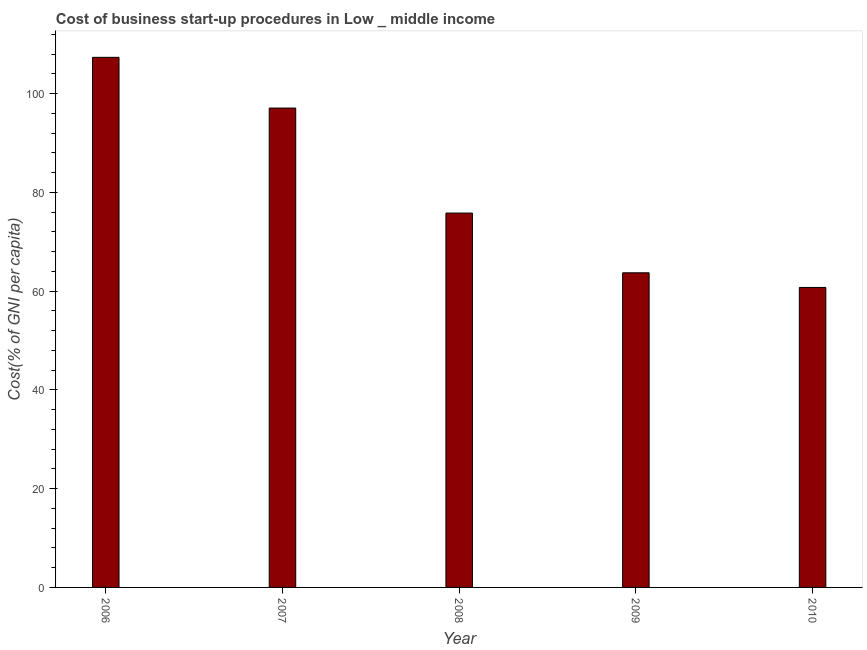Does the graph contain any zero values?
Your answer should be compact. No. What is the title of the graph?
Make the answer very short. Cost of business start-up procedures in Low _ middle income. What is the label or title of the Y-axis?
Provide a succinct answer. Cost(% of GNI per capita). What is the cost of business startup procedures in 2009?
Your answer should be very brief. 63.72. Across all years, what is the maximum cost of business startup procedures?
Provide a succinct answer. 107.35. Across all years, what is the minimum cost of business startup procedures?
Provide a succinct answer. 60.75. In which year was the cost of business startup procedures maximum?
Give a very brief answer. 2006. In which year was the cost of business startup procedures minimum?
Ensure brevity in your answer.  2010. What is the sum of the cost of business startup procedures?
Make the answer very short. 404.7. What is the difference between the cost of business startup procedures in 2007 and 2008?
Your answer should be compact. 21.27. What is the average cost of business startup procedures per year?
Ensure brevity in your answer.  80.94. What is the median cost of business startup procedures?
Your response must be concise. 75.81. Do a majority of the years between 2010 and 2007 (inclusive) have cost of business startup procedures greater than 20 %?
Keep it short and to the point. Yes. What is the ratio of the cost of business startup procedures in 2007 to that in 2009?
Your response must be concise. 1.52. Is the cost of business startup procedures in 2008 less than that in 2010?
Offer a very short reply. No. What is the difference between the highest and the second highest cost of business startup procedures?
Ensure brevity in your answer.  10.27. Is the sum of the cost of business startup procedures in 2008 and 2009 greater than the maximum cost of business startup procedures across all years?
Offer a very short reply. Yes. What is the difference between the highest and the lowest cost of business startup procedures?
Your response must be concise. 46.6. How many bars are there?
Ensure brevity in your answer.  5. Are the values on the major ticks of Y-axis written in scientific E-notation?
Offer a terse response. No. What is the Cost(% of GNI per capita) of 2006?
Give a very brief answer. 107.35. What is the Cost(% of GNI per capita) of 2007?
Provide a succinct answer. 97.08. What is the Cost(% of GNI per capita) of 2008?
Your response must be concise. 75.81. What is the Cost(% of GNI per capita) of 2009?
Make the answer very short. 63.72. What is the Cost(% of GNI per capita) in 2010?
Keep it short and to the point. 60.75. What is the difference between the Cost(% of GNI per capita) in 2006 and 2007?
Offer a very short reply. 10.27. What is the difference between the Cost(% of GNI per capita) in 2006 and 2008?
Give a very brief answer. 31.54. What is the difference between the Cost(% of GNI per capita) in 2006 and 2009?
Your answer should be very brief. 43.63. What is the difference between the Cost(% of GNI per capita) in 2006 and 2010?
Make the answer very short. 46.6. What is the difference between the Cost(% of GNI per capita) in 2007 and 2008?
Make the answer very short. 21.27. What is the difference between the Cost(% of GNI per capita) in 2007 and 2009?
Keep it short and to the point. 33.36. What is the difference between the Cost(% of GNI per capita) in 2007 and 2010?
Keep it short and to the point. 36.33. What is the difference between the Cost(% of GNI per capita) in 2008 and 2009?
Provide a succinct answer. 12.1. What is the difference between the Cost(% of GNI per capita) in 2008 and 2010?
Your answer should be very brief. 15.06. What is the difference between the Cost(% of GNI per capita) in 2009 and 2010?
Your answer should be compact. 2.97. What is the ratio of the Cost(% of GNI per capita) in 2006 to that in 2007?
Provide a short and direct response. 1.11. What is the ratio of the Cost(% of GNI per capita) in 2006 to that in 2008?
Your answer should be very brief. 1.42. What is the ratio of the Cost(% of GNI per capita) in 2006 to that in 2009?
Make the answer very short. 1.69. What is the ratio of the Cost(% of GNI per capita) in 2006 to that in 2010?
Make the answer very short. 1.77. What is the ratio of the Cost(% of GNI per capita) in 2007 to that in 2008?
Give a very brief answer. 1.28. What is the ratio of the Cost(% of GNI per capita) in 2007 to that in 2009?
Keep it short and to the point. 1.52. What is the ratio of the Cost(% of GNI per capita) in 2007 to that in 2010?
Make the answer very short. 1.6. What is the ratio of the Cost(% of GNI per capita) in 2008 to that in 2009?
Your answer should be very brief. 1.19. What is the ratio of the Cost(% of GNI per capita) in 2008 to that in 2010?
Your answer should be compact. 1.25. What is the ratio of the Cost(% of GNI per capita) in 2009 to that in 2010?
Offer a very short reply. 1.05. 